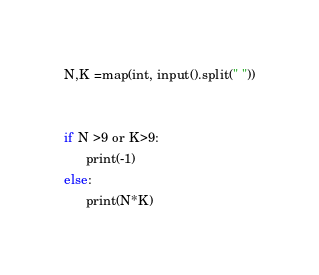<code> <loc_0><loc_0><loc_500><loc_500><_Python_>N,K =map(int, input().split(" "))


if N >9 or K>9:
      print(-1)
else:
      print(N*K)


</code> 